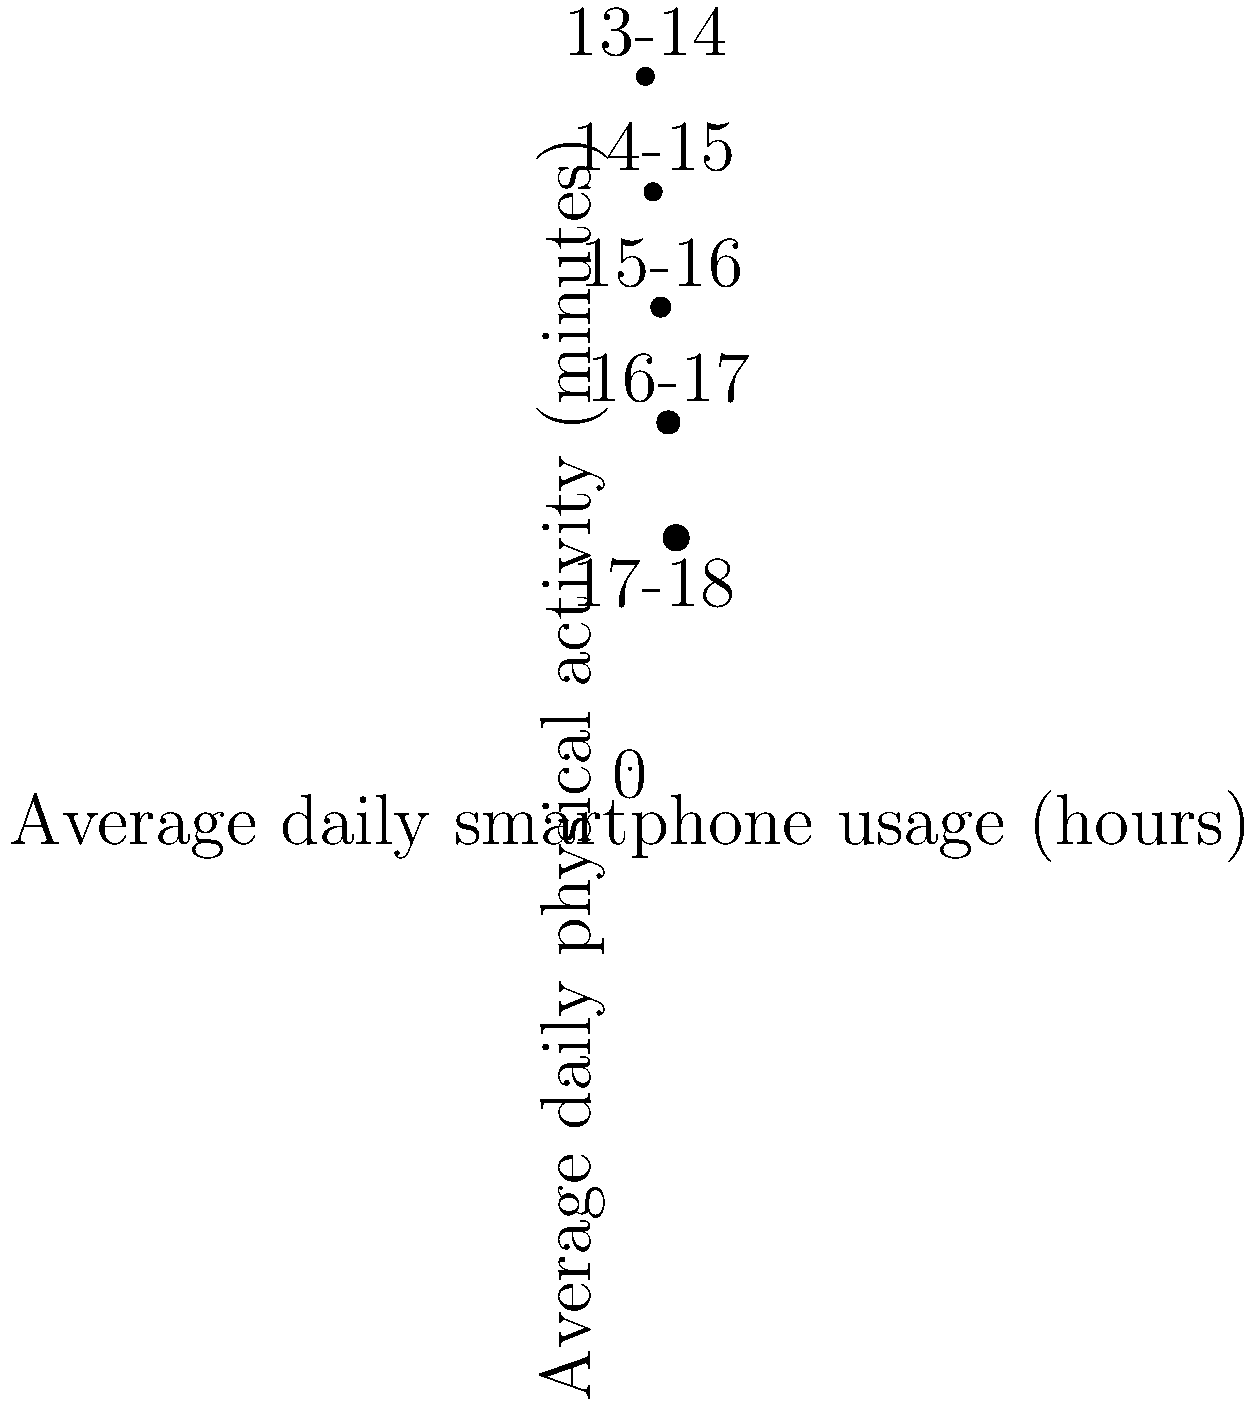Based on the bubble chart showing the relationship between average daily smartphone usage and physical activity levels in teenagers, what trend can be observed as smartphone usage increases? How might this trend impact the physical and mental health of adolescents? To answer this question, let's analyze the bubble chart step-by-step:

1. The x-axis represents average daily smartphone usage in hours, while the y-axis shows average daily physical activity in minutes.

2. Each bubble represents a different age group of teenagers, from 13-14 to 17-18 years old.

3. Observing the chart from left to right, we can see that:
   a. As smartphone usage increases, physical activity decreases.
   b. The bubble size increases, indicating older age groups.

4. The trend shows an inverse relationship between smartphone usage and physical activity:
   - 13-14 year-olds: ~2 hours of smartphone use, ~90 minutes of physical activity
   - 17-18 year-olds: ~6 hours of smartphone use, ~30 minutes of physical activity

5. Potential impacts on physical health:
   a. Decreased physical activity may lead to obesity, cardiovascular issues, and reduced overall fitness.
   b. Prolonged screen time might cause eye strain and poor posture.

6. Potential impacts on mental health:
   a. Reduced physical activity may lead to decreased endorphin production, potentially affecting mood and stress levels.
   b. Increased smartphone use might lead to social media addiction, cyberbullying exposure, and sleep disturbances.

7. The trend suggests that as teenagers age, they spend more time on smartphones and less time being physically active, which could have compounding negative effects on their overall health and development.
Answer: Inverse relationship between smartphone usage and physical activity, potentially leading to negative physical and mental health outcomes in adolescents. 